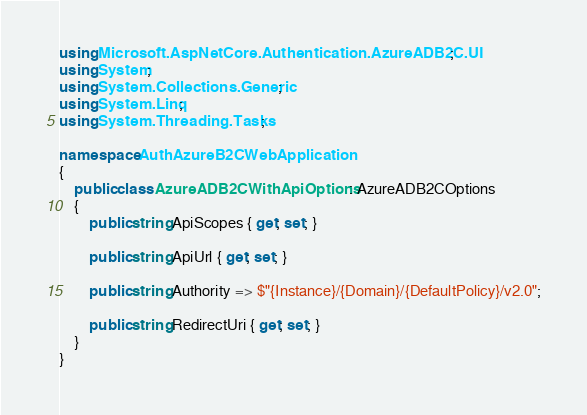<code> <loc_0><loc_0><loc_500><loc_500><_C#_>using Microsoft.AspNetCore.Authentication.AzureADB2C.UI;
using System;
using System.Collections.Generic;
using System.Linq;
using System.Threading.Tasks;

namespace AuthAzureB2CWebApplication
{
    public class AzureADB2CWithApiOptions : AzureADB2COptions
    {
        public string ApiScopes { get; set; }

        public string ApiUrl { get; set; }

        public string Authority => $"{Instance}/{Domain}/{DefaultPolicy}/v2.0";

        public string RedirectUri { get; set; }
    }
}
</code> 